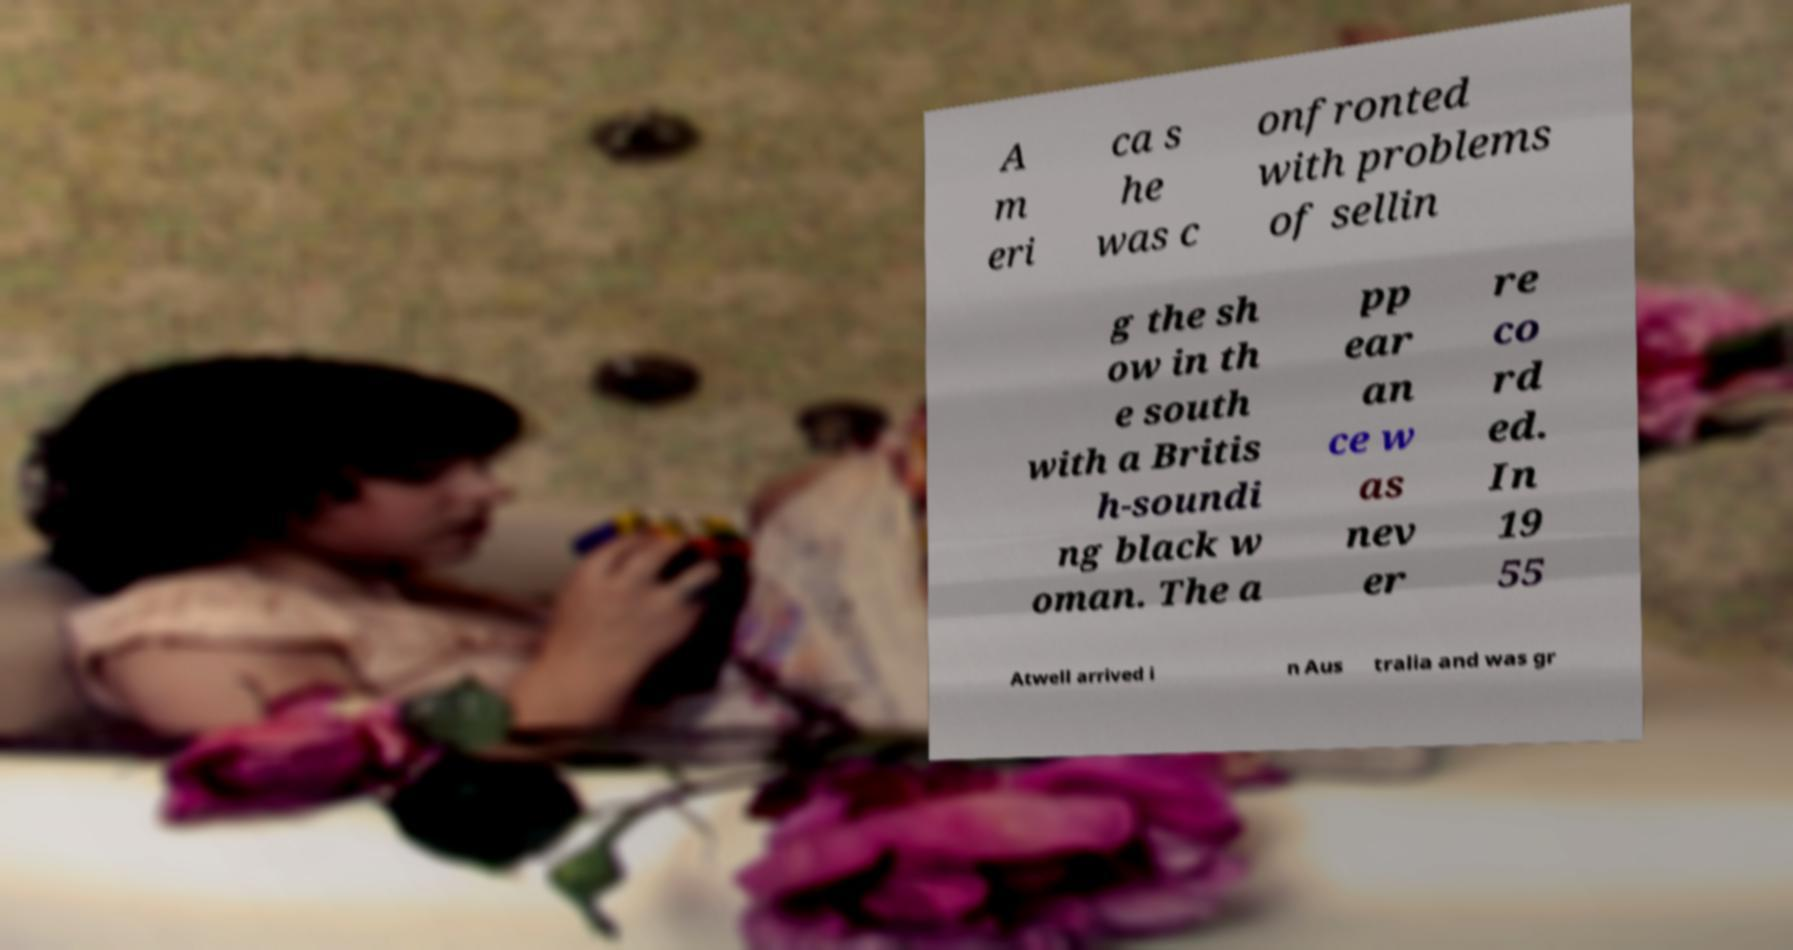Can you accurately transcribe the text from the provided image for me? A m eri ca s he was c onfronted with problems of sellin g the sh ow in th e south with a Britis h-soundi ng black w oman. The a pp ear an ce w as nev er re co rd ed. In 19 55 Atwell arrived i n Aus tralia and was gr 